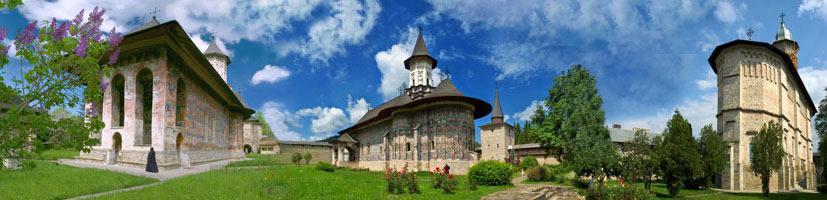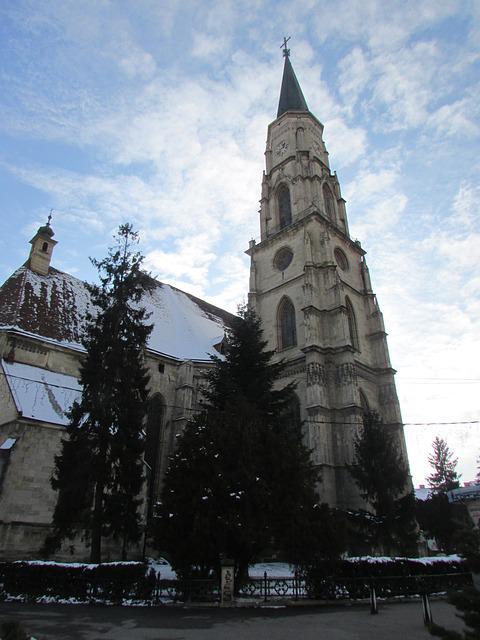The first image is the image on the left, the second image is the image on the right. Evaluate the accuracy of this statement regarding the images: "At least one image shows a building with a cone-shape atop a cylinder.". Is it true? Answer yes or no. Yes. The first image is the image on the left, the second image is the image on the right. Assess this claim about the two images: "There is a conical roof in one of the images.". Correct or not? Answer yes or no. Yes. 